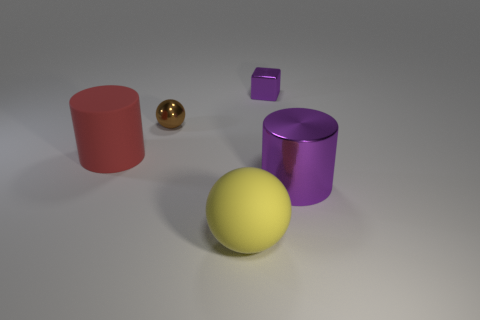What number of things are both left of the block and to the right of the red matte object?
Your answer should be compact. 2. Are there any yellow objects that have the same material as the big purple cylinder?
Offer a very short reply. No. There is a object to the left of the small thing in front of the tiny purple shiny thing; what is its material?
Offer a terse response. Rubber. Are there an equal number of spheres behind the small purple cube and big metallic cylinders that are on the left side of the large metallic cylinder?
Ensure brevity in your answer.  Yes. Is the large purple shiny thing the same shape as the small purple metallic thing?
Offer a terse response. No. There is a large thing that is both on the right side of the red cylinder and left of the block; what material is it made of?
Provide a short and direct response. Rubber. What number of small brown metal things are the same shape as the big yellow matte thing?
Provide a succinct answer. 1. There is a cylinder that is to the right of the cylinder behind the purple shiny object in front of the large red matte thing; what size is it?
Keep it short and to the point. Large. Is the number of big purple cylinders that are in front of the matte sphere greater than the number of large purple metallic cylinders?
Make the answer very short. No. Are any red matte objects visible?
Your answer should be very brief. Yes. 